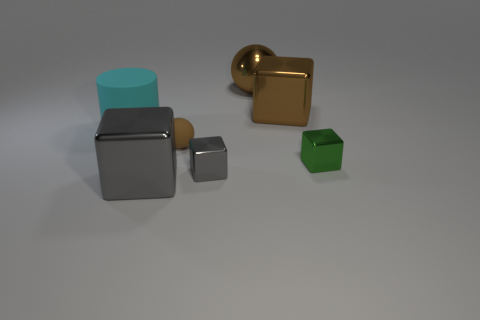Add 1 tiny spheres. How many objects exist? 8 Subtract all blocks. How many objects are left? 3 Subtract all tiny green shiny objects. Subtract all large metal cubes. How many objects are left? 4 Add 6 large brown metallic things. How many large brown metallic things are left? 8 Add 5 tiny blue metal objects. How many tiny blue metal objects exist? 5 Subtract 0 gray balls. How many objects are left? 7 